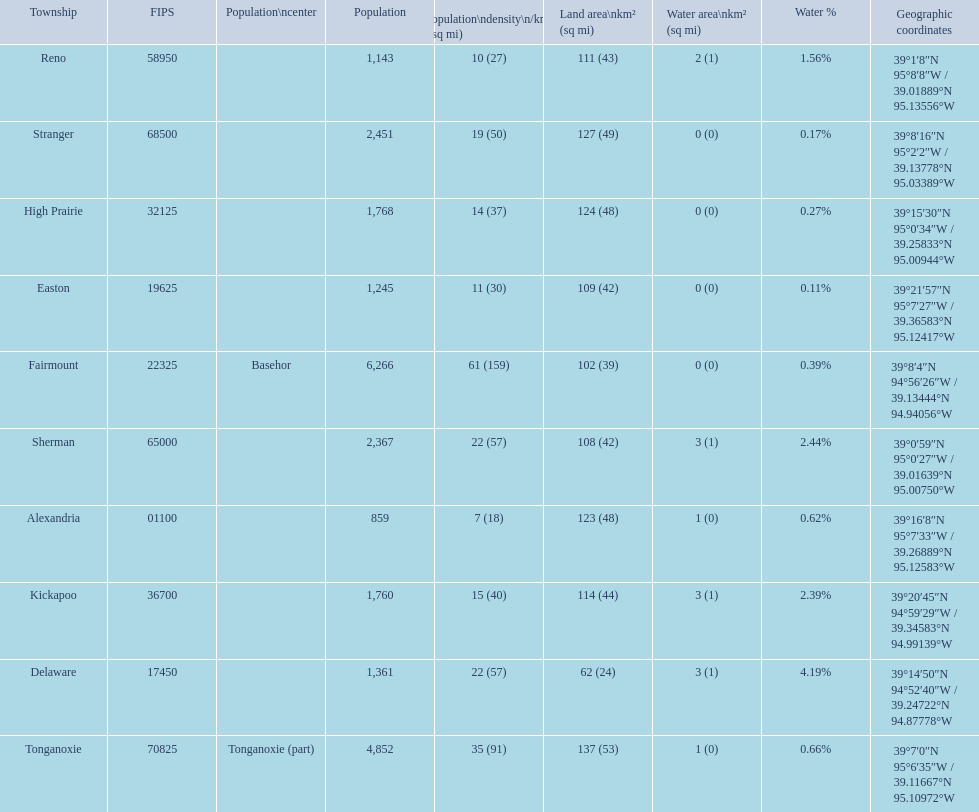Does alexandria county have a higher or lower population than delaware county? Lower. 